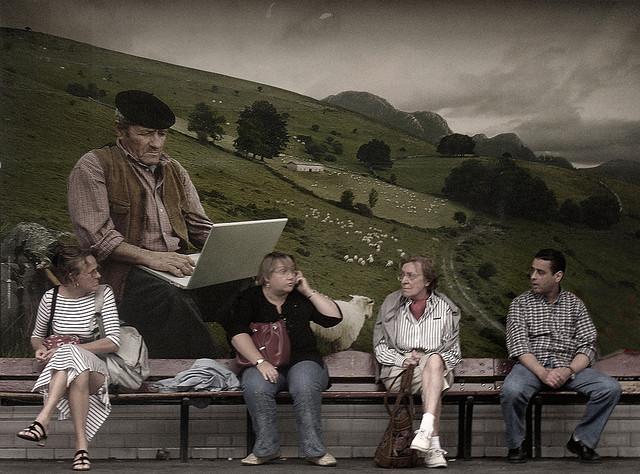Is the man real?
Keep it brief. No. Are the fields shown intended for agriculture or livestock?
Quick response, please. Livestock. Is the man in the background eating children in the photo?
Keep it brief. No. 